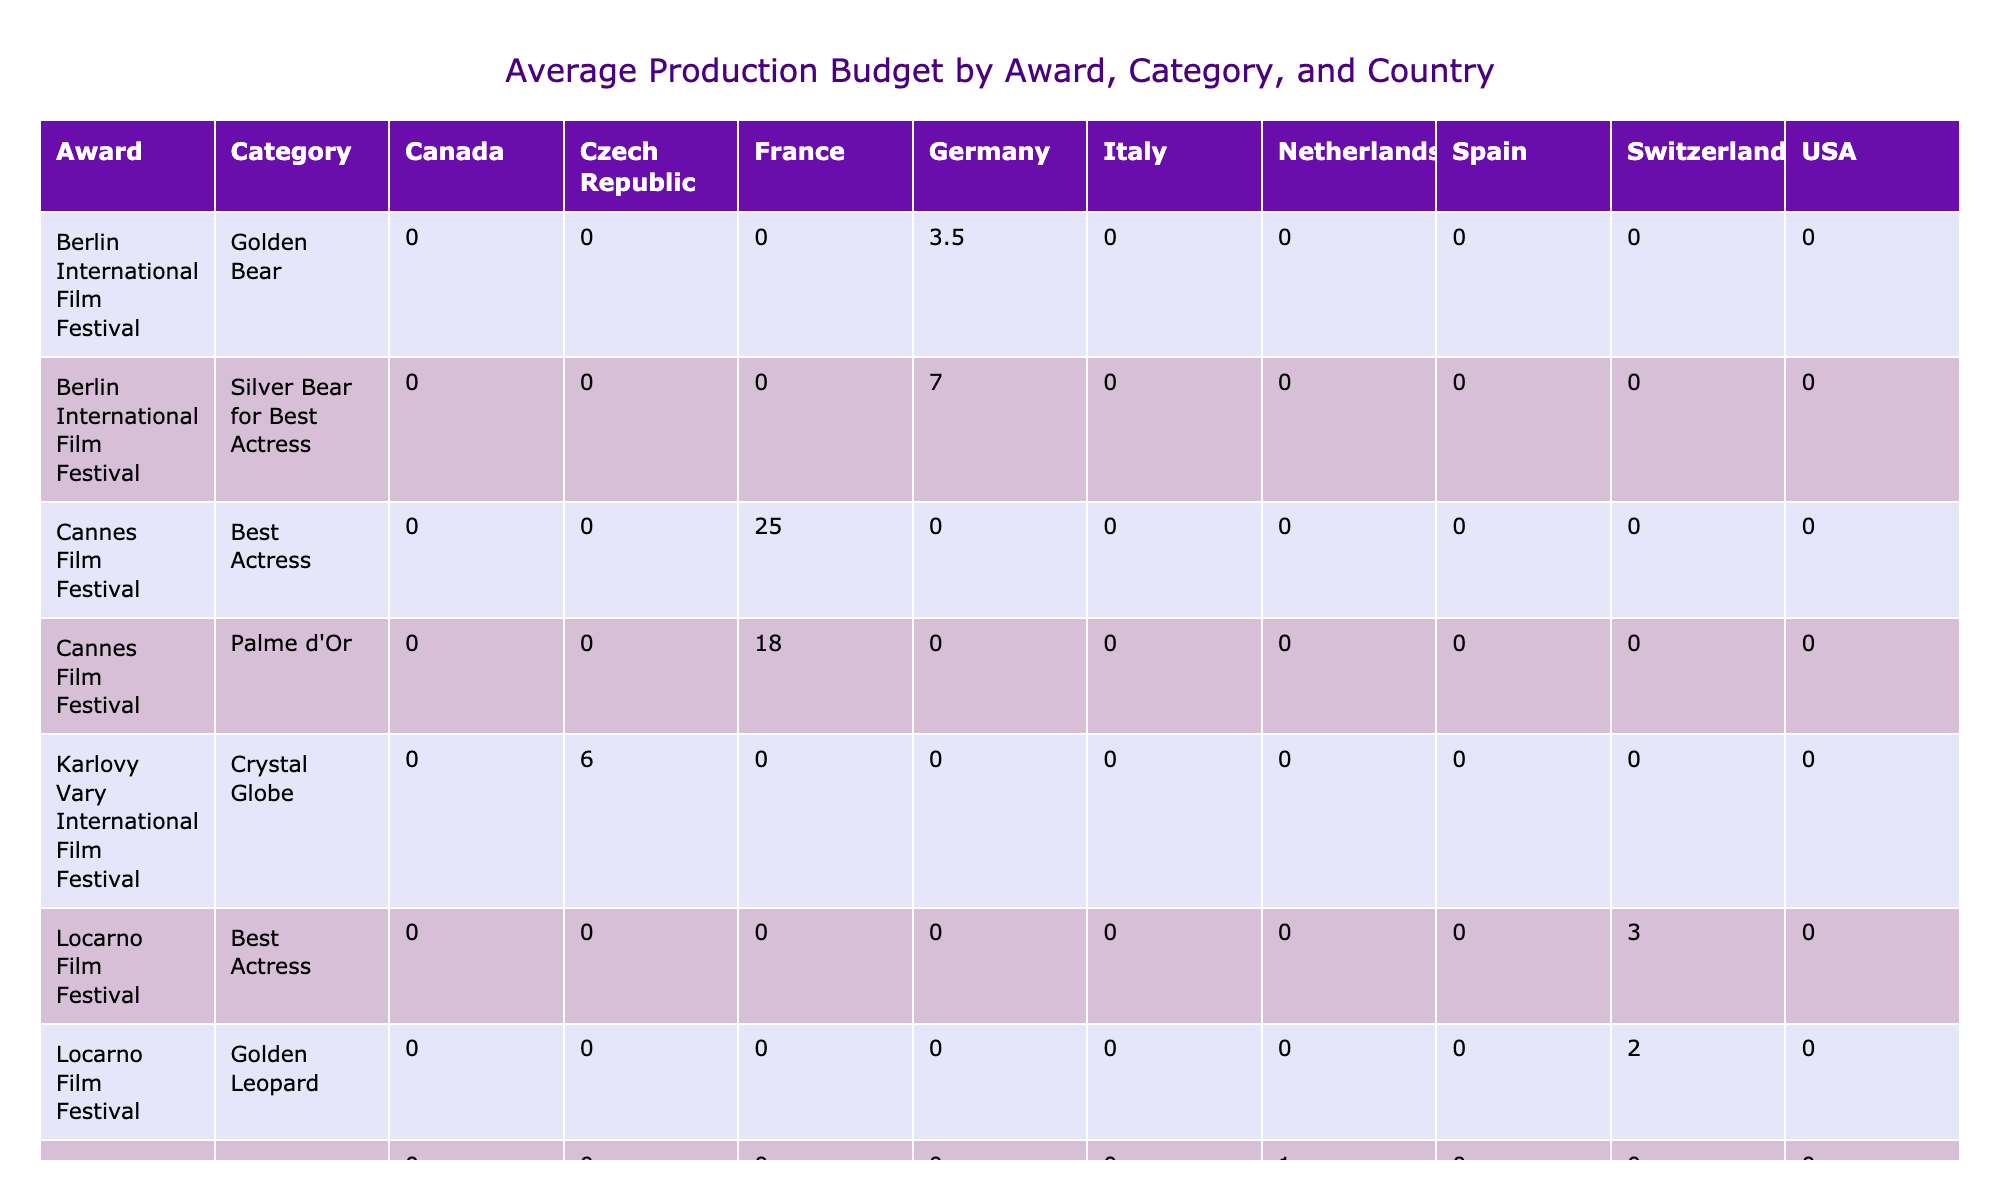What is the highest production budget reported in the table? The table lists the production budgets for each award and category. The highest value among them is 25 million associated with the "Best Actress" category at the Cannes Film Festival.
Answer: 25 million Which country had the lowest average production budget across all categories? The Netherlands has two entries: 1.5 million for the "Tiger Award" and 1 million for the "Hivos Tiger Award." Averaging these values gives (1.5 + 1) / 2 = 1.25 million, which is lower than any other country.
Answer: Netherlands Did any films from Canada win an award with a production budget above 20 million? Only the "People's Choice Award" with a budget of 20 million is listed for Canada. Thus, there are no awards exceeding 20 million from Canada in the table.
Answer: No What is the average production budget for films that won the "Best Actress" award in the table? There are three entries listed under the "Best Actress" award: 25 million (Cannes), 12 million (Venice), and 3 million (Locarno). Summing these gives 25 + 12 + 3 = 40 million, and dividing by 3 provides an average of 40 / 3 = approximately 13.33 million.
Answer: Approximately 13.33 million Which category has the highest overall production budget among the awards listed? To find this, we need to sum the production budgets for each category. For example, "Palme d'Or" totals 18 million, "Best Actress" totals to 40 million, and others must be summed similarly. The highest total will be for "Best Actress," with its total from three awards amounting to 40 million.
Answer: Best Actress Is the "Golden Lion" award given to films from Italy associated with a higher or lower production budget than the "Silver Bear for Best Actress" from Germany? The "Golden Lion" (Italy) has a production budget of 15 million, while the "Silver Bear for Best Actress" (Germany) has a budget of 7 million. Since 15 million is greater than 7 million, the "Golden Lion" has a higher budget.
Answer: Higher What is the production budget difference between the highest and lowest production budget for films from Spain? For Spain, the "Golden Shell" award has a budget of 10 million, while the "Silver Shell for Best Actress" has 9 million. The difference is 10 - 9 = 1 million.
Answer: 1 million Which festival awarded the "Tigers Award" to a film with the lowest production budget? The "Tiger Award" from the Rotterdam International Film Festival is awarded to a film with a production budget of 1.5 million, which is the lowest in the data set.
Answer: Rotterdam International Film Festival 